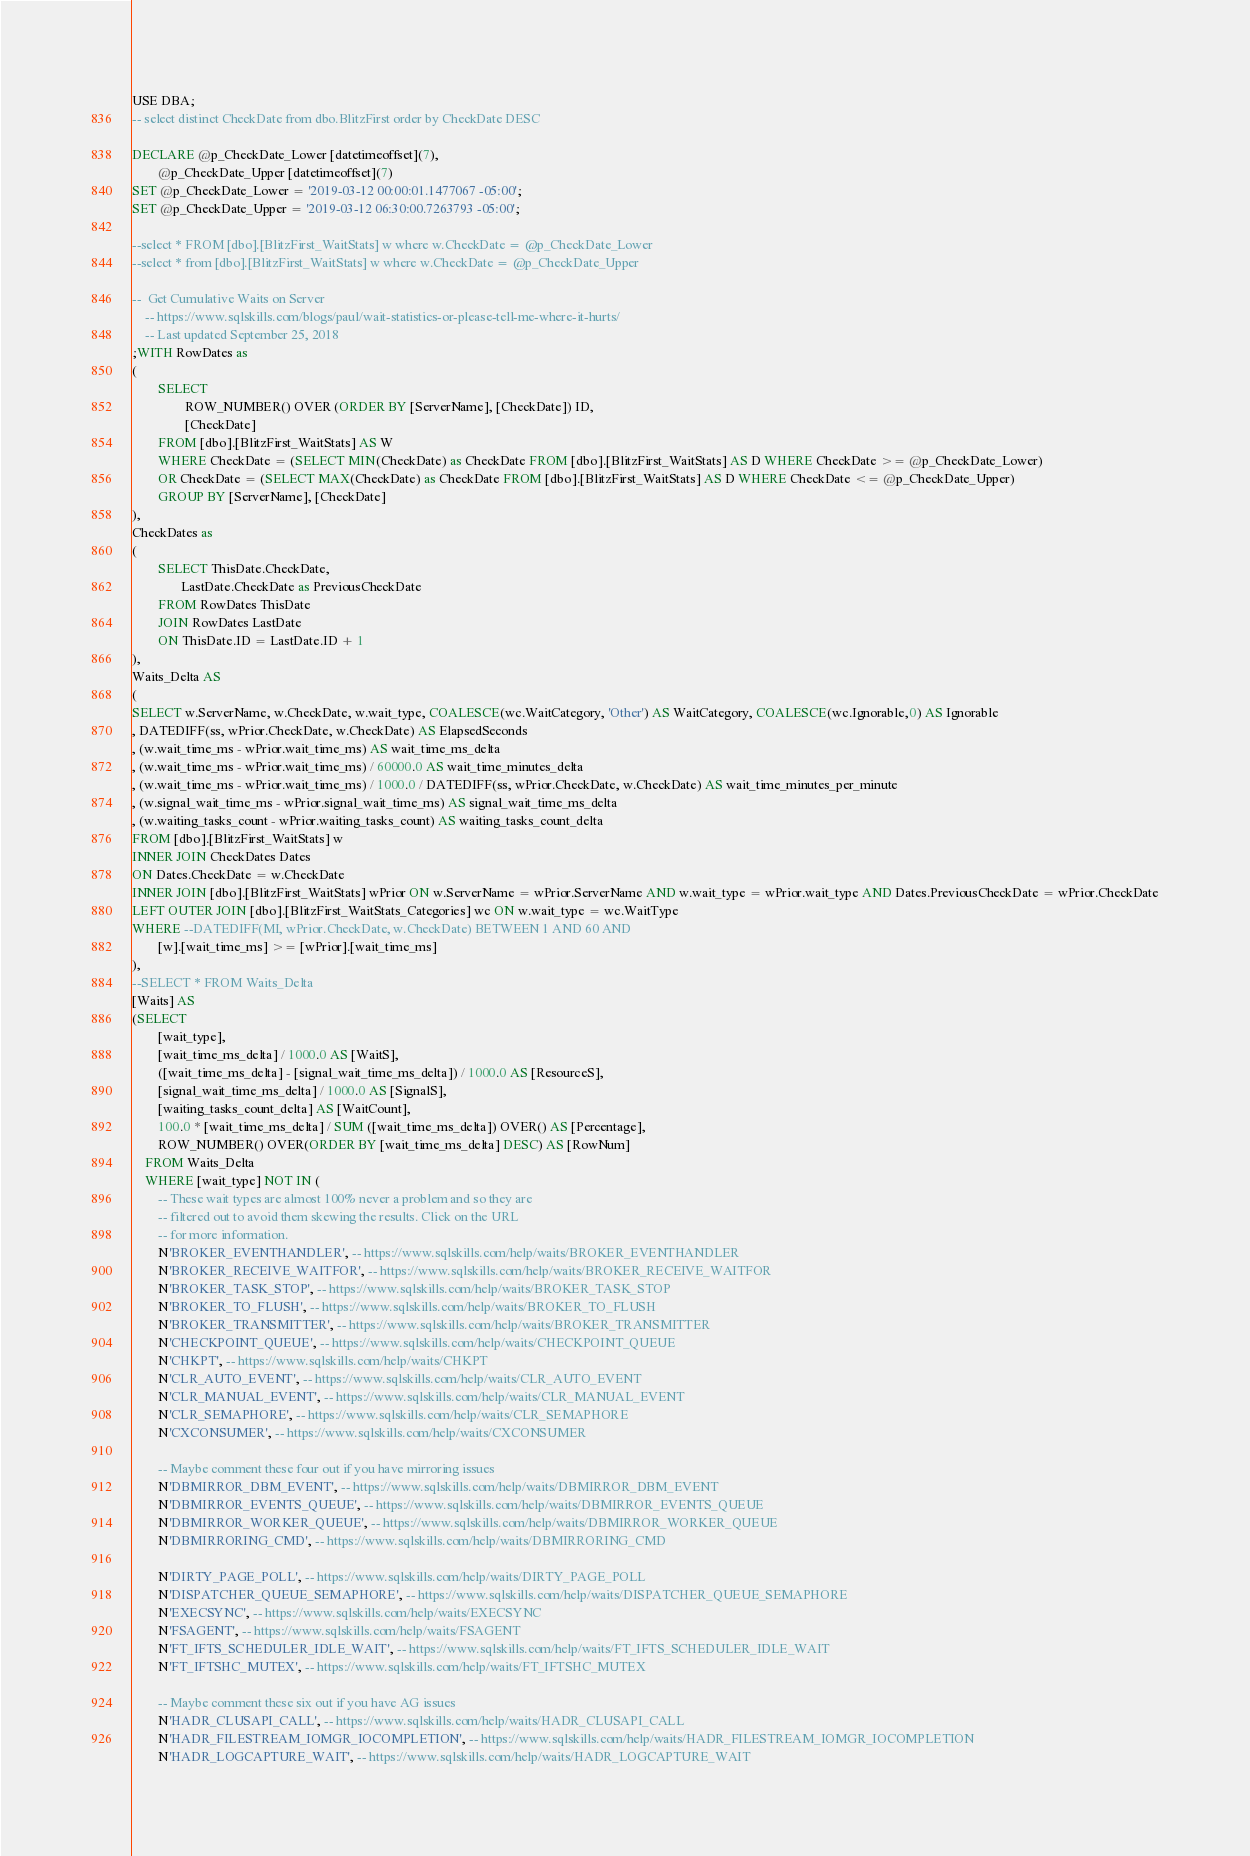Convert code to text. <code><loc_0><loc_0><loc_500><loc_500><_SQL_>USE DBA;
-- select distinct CheckDate from dbo.BlitzFirst order by CheckDate DESC

DECLARE @p_CheckDate_Lower [datetimeoffset](7),
		@p_CheckDate_Upper [datetimeoffset](7)
SET @p_CheckDate_Lower = '2019-03-12 00:00:01.1477067 -05:00';
SET @p_CheckDate_Upper = '2019-03-12 06:30:00.7263793 -05:00';

--select * FROM [dbo].[BlitzFirst_WaitStats] w where w.CheckDate = @p_CheckDate_Lower
--select * from [dbo].[BlitzFirst_WaitStats] w where w.CheckDate = @p_CheckDate_Upper

--	Get Cumulative Waits on Server
	-- https://www.sqlskills.com/blogs/paul/wait-statistics-or-please-tell-me-where-it-hurts/
	-- Last updated September 25, 2018
;WITH RowDates as
(
        SELECT 
                ROW_NUMBER() OVER (ORDER BY [ServerName], [CheckDate]) ID,
                [CheckDate]
        FROM [dbo].[BlitzFirst_WaitStats] AS W
		WHERE CheckDate = (SELECT MIN(CheckDate) as CheckDate FROM [dbo].[BlitzFirst_WaitStats] AS D WHERE CheckDate >= @p_CheckDate_Lower)
		OR CheckDate = (SELECT MAX(CheckDate) as CheckDate FROM [dbo].[BlitzFirst_WaitStats] AS D WHERE CheckDate <= @p_CheckDate_Upper)
        GROUP BY [ServerName], [CheckDate]
),
CheckDates as
(
        SELECT ThisDate.CheckDate,
               LastDate.CheckDate as PreviousCheckDate
        FROM RowDates ThisDate
        JOIN RowDates LastDate
        ON ThisDate.ID = LastDate.ID + 1
),
Waits_Delta AS
(
SELECT w.ServerName, w.CheckDate, w.wait_type, COALESCE(wc.WaitCategory, 'Other') AS WaitCategory, COALESCE(wc.Ignorable,0) AS Ignorable
, DATEDIFF(ss, wPrior.CheckDate, w.CheckDate) AS ElapsedSeconds
, (w.wait_time_ms - wPrior.wait_time_ms) AS wait_time_ms_delta
, (w.wait_time_ms - wPrior.wait_time_ms) / 60000.0 AS wait_time_minutes_delta
, (w.wait_time_ms - wPrior.wait_time_ms) / 1000.0 / DATEDIFF(ss, wPrior.CheckDate, w.CheckDate) AS wait_time_minutes_per_minute
, (w.signal_wait_time_ms - wPrior.signal_wait_time_ms) AS signal_wait_time_ms_delta
, (w.waiting_tasks_count - wPrior.waiting_tasks_count) AS waiting_tasks_count_delta
FROM [dbo].[BlitzFirst_WaitStats] w
INNER JOIN CheckDates Dates
ON Dates.CheckDate = w.CheckDate
INNER JOIN [dbo].[BlitzFirst_WaitStats] wPrior ON w.ServerName = wPrior.ServerName AND w.wait_type = wPrior.wait_type AND Dates.PreviousCheckDate = wPrior.CheckDate
LEFT OUTER JOIN [dbo].[BlitzFirst_WaitStats_Categories] wc ON w.wait_type = wc.WaitType
WHERE --DATEDIFF(MI, wPrior.CheckDate, w.CheckDate) BETWEEN 1 AND 60 AND 
		[w].[wait_time_ms] >= [wPrior].[wait_time_ms]
),
--SELECT * FROM Waits_Delta
[Waits] AS
(SELECT
        [wait_type],
        [wait_time_ms_delta] / 1000.0 AS [WaitS],
        ([wait_time_ms_delta] - [signal_wait_time_ms_delta]) / 1000.0 AS [ResourceS],
        [signal_wait_time_ms_delta] / 1000.0 AS [SignalS],
        [waiting_tasks_count_delta] AS [WaitCount],
        100.0 * [wait_time_ms_delta] / SUM ([wait_time_ms_delta]) OVER() AS [Percentage],
        ROW_NUMBER() OVER(ORDER BY [wait_time_ms_delta] DESC) AS [RowNum]
    FROM Waits_Delta
	WHERE [wait_type] NOT IN (
        -- These wait types are almost 100% never a problem and so they are
        -- filtered out to avoid them skewing the results. Click on the URL
        -- for more information.
        N'BROKER_EVENTHANDLER', -- https://www.sqlskills.com/help/waits/BROKER_EVENTHANDLER
        N'BROKER_RECEIVE_WAITFOR', -- https://www.sqlskills.com/help/waits/BROKER_RECEIVE_WAITFOR
        N'BROKER_TASK_STOP', -- https://www.sqlskills.com/help/waits/BROKER_TASK_STOP
        N'BROKER_TO_FLUSH', -- https://www.sqlskills.com/help/waits/BROKER_TO_FLUSH
        N'BROKER_TRANSMITTER', -- https://www.sqlskills.com/help/waits/BROKER_TRANSMITTER
        N'CHECKPOINT_QUEUE', -- https://www.sqlskills.com/help/waits/CHECKPOINT_QUEUE
        N'CHKPT', -- https://www.sqlskills.com/help/waits/CHKPT
        N'CLR_AUTO_EVENT', -- https://www.sqlskills.com/help/waits/CLR_AUTO_EVENT
        N'CLR_MANUAL_EVENT', -- https://www.sqlskills.com/help/waits/CLR_MANUAL_EVENT
        N'CLR_SEMAPHORE', -- https://www.sqlskills.com/help/waits/CLR_SEMAPHORE
        N'CXCONSUMER', -- https://www.sqlskills.com/help/waits/CXCONSUMER
 
        -- Maybe comment these four out if you have mirroring issues
        N'DBMIRROR_DBM_EVENT', -- https://www.sqlskills.com/help/waits/DBMIRROR_DBM_EVENT
        N'DBMIRROR_EVENTS_QUEUE', -- https://www.sqlskills.com/help/waits/DBMIRROR_EVENTS_QUEUE
        N'DBMIRROR_WORKER_QUEUE', -- https://www.sqlskills.com/help/waits/DBMIRROR_WORKER_QUEUE
        N'DBMIRRORING_CMD', -- https://www.sqlskills.com/help/waits/DBMIRRORING_CMD
 
        N'DIRTY_PAGE_POLL', -- https://www.sqlskills.com/help/waits/DIRTY_PAGE_POLL
        N'DISPATCHER_QUEUE_SEMAPHORE', -- https://www.sqlskills.com/help/waits/DISPATCHER_QUEUE_SEMAPHORE
        N'EXECSYNC', -- https://www.sqlskills.com/help/waits/EXECSYNC
        N'FSAGENT', -- https://www.sqlskills.com/help/waits/FSAGENT
        N'FT_IFTS_SCHEDULER_IDLE_WAIT', -- https://www.sqlskills.com/help/waits/FT_IFTS_SCHEDULER_IDLE_WAIT
        N'FT_IFTSHC_MUTEX', -- https://www.sqlskills.com/help/waits/FT_IFTSHC_MUTEX
 
        -- Maybe comment these six out if you have AG issues
        N'HADR_CLUSAPI_CALL', -- https://www.sqlskills.com/help/waits/HADR_CLUSAPI_CALL
        N'HADR_FILESTREAM_IOMGR_IOCOMPLETION', -- https://www.sqlskills.com/help/waits/HADR_FILESTREAM_IOMGR_IOCOMPLETION
        N'HADR_LOGCAPTURE_WAIT', -- https://www.sqlskills.com/help/waits/HADR_LOGCAPTURE_WAIT</code> 